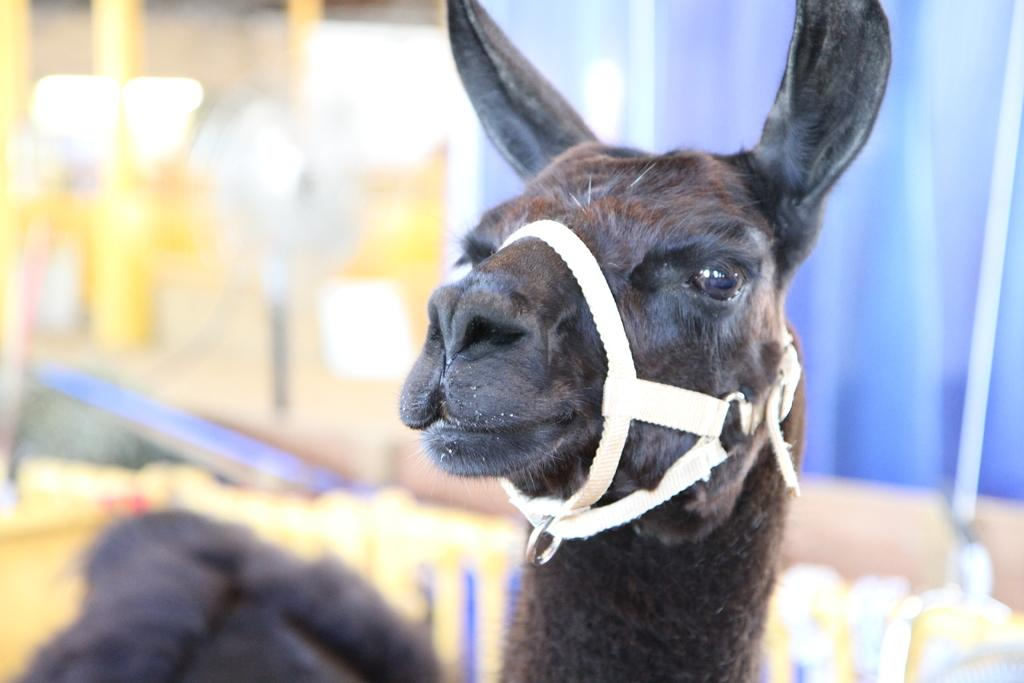What type of creature is present in the image? There is an animal in the image. Can you describe the background of the image? The background of the image is blurred. What type of milk is the animal drinking in the image? There is no milk present in the image, and the animal's actions are not described. How many horses are visible in the image? There is no mention of a horse in the image, only an animal. 